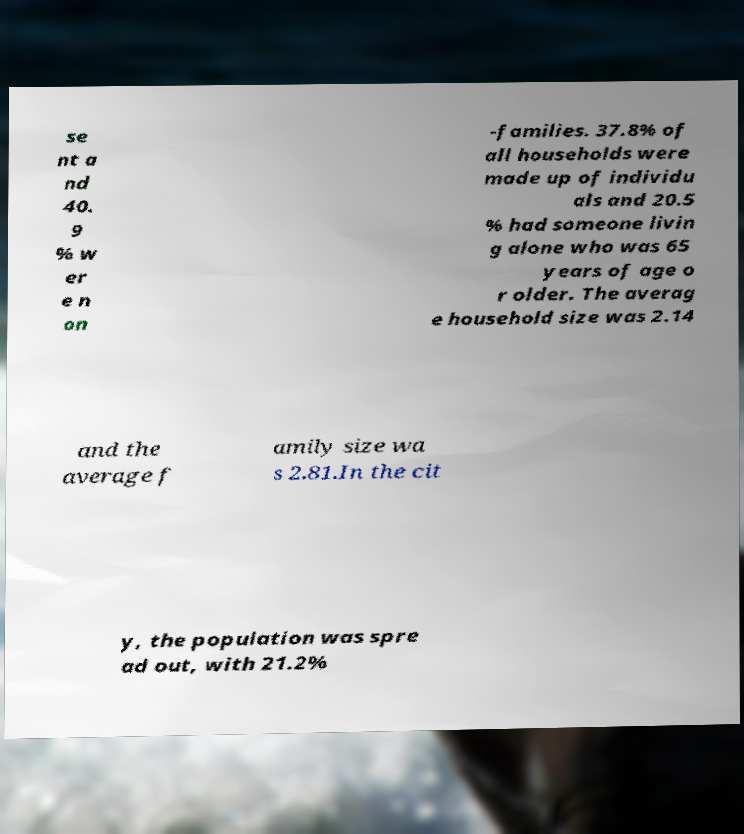Can you read and provide the text displayed in the image?This photo seems to have some interesting text. Can you extract and type it out for me? se nt a nd 40. 9 % w er e n on -families. 37.8% of all households were made up of individu als and 20.5 % had someone livin g alone who was 65 years of age o r older. The averag e household size was 2.14 and the average f amily size wa s 2.81.In the cit y, the population was spre ad out, with 21.2% 